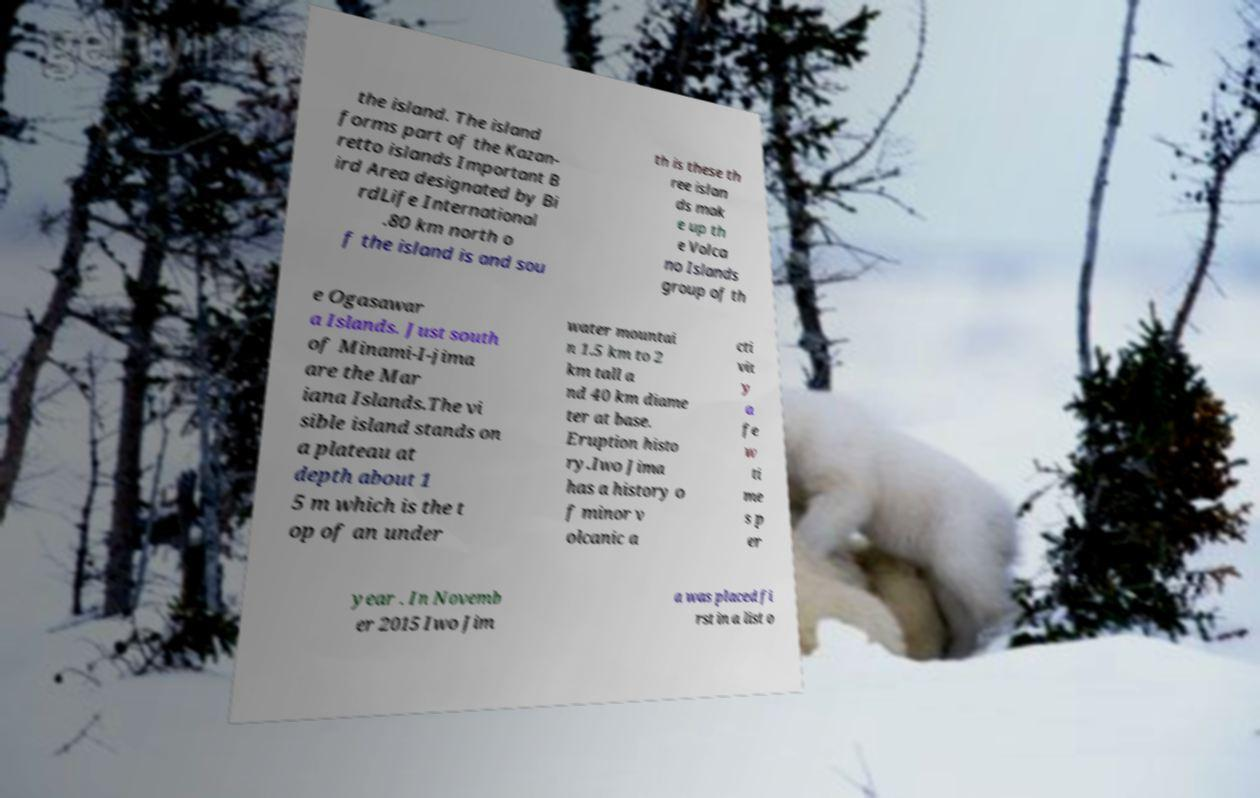I need the written content from this picture converted into text. Can you do that? the island. The island forms part of the Kazan- retto islands Important B ird Area designated by Bi rdLife International .80 km north o f the island is and sou th is these th ree islan ds mak e up th e Volca no Islands group of th e Ogasawar a Islands. Just south of Minami-I-jima are the Mar iana Islands.The vi sible island stands on a plateau at depth about 1 5 m which is the t op of an under water mountai n 1.5 km to 2 km tall a nd 40 km diame ter at base. Eruption histo ry.Iwo Jima has a history o f minor v olcanic a cti vit y a fe w ti me s p er year . In Novemb er 2015 Iwo Jim a was placed fi rst in a list o 